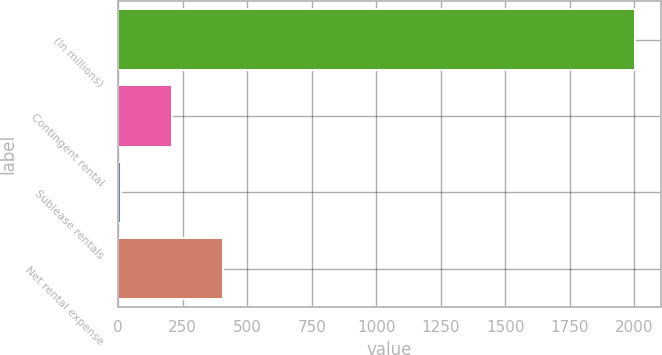Convert chart to OTSL. <chart><loc_0><loc_0><loc_500><loc_500><bar_chart><fcel>(In millions)<fcel>Contingent rental<fcel>Sublease rentals<fcel>Net rental expense<nl><fcel>2003<fcel>208.4<fcel>9<fcel>407.8<nl></chart> 